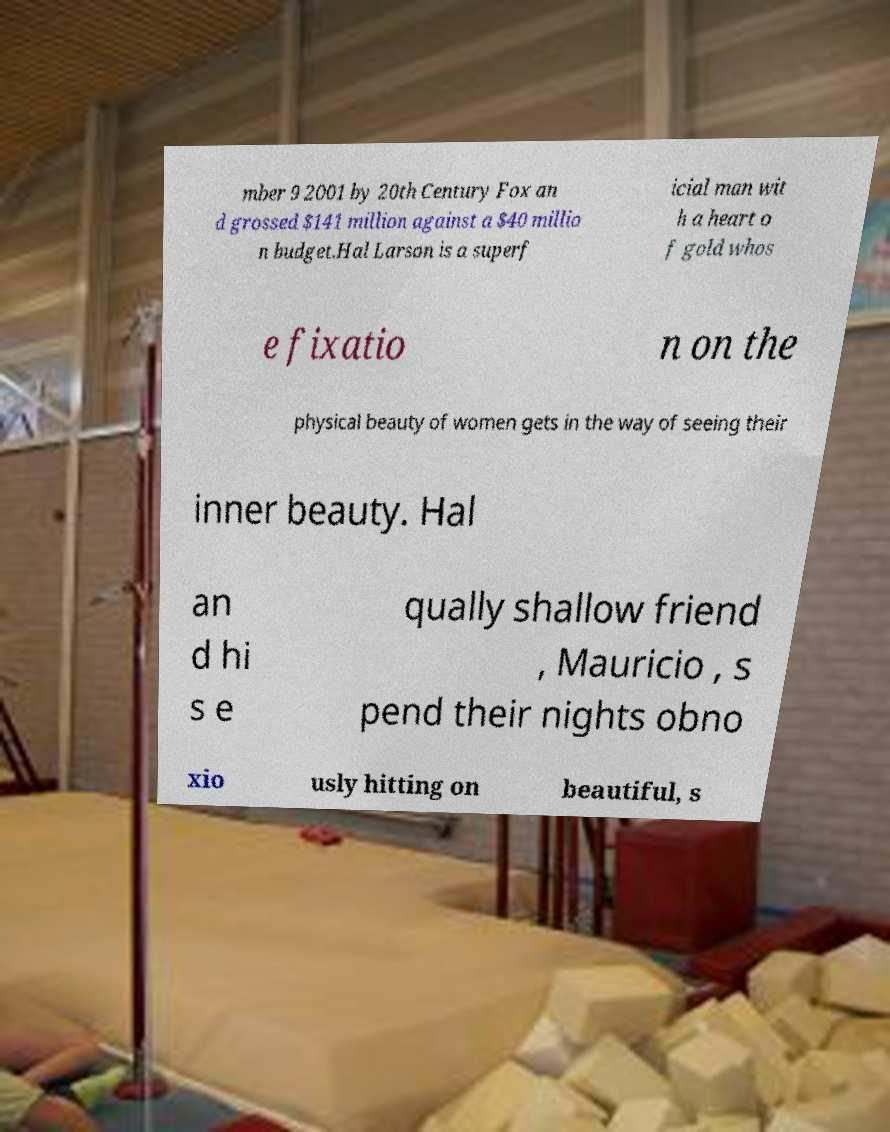Please identify and transcribe the text found in this image. mber 9 2001 by 20th Century Fox an d grossed $141 million against a $40 millio n budget.Hal Larson is a superf icial man wit h a heart o f gold whos e fixatio n on the physical beauty of women gets in the way of seeing their inner beauty. Hal an d hi s e qually shallow friend , Mauricio , s pend their nights obno xio usly hitting on beautiful, s 